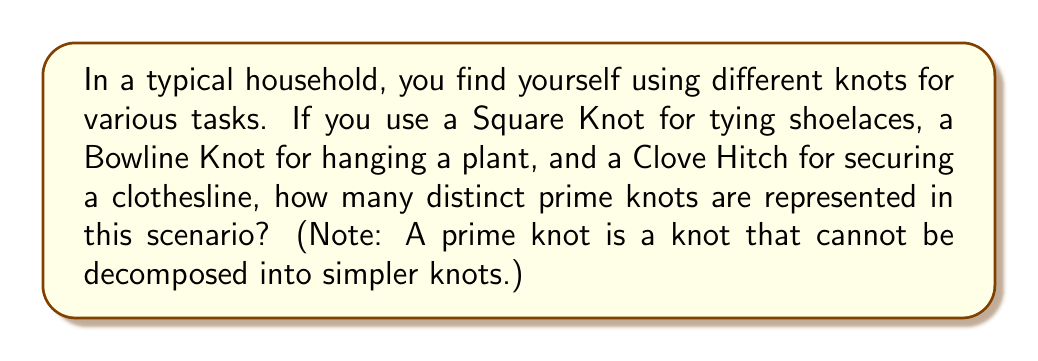Help me with this question. To solve this problem, we need to analyze each knot mentioned and determine if it's a prime knot:

1. Square Knot:
   The Square Knot, also known as the Reef Knot, is actually composed of two trefoil knots. In mathematical notation:
   Square Knot = Trefoil Knot # Mirror Trefoil Knot
   Where # denotes the connect sum operation.
   Therefore, the Square Knot is not a prime knot.

2. Bowline Knot:
   The Bowline Knot, when closed to form a loop, is equivalent to the Figure-8 Knot in knot theory. The Figure-8 Knot is a prime knot, denoted as $4_1$ in knot notation.

3. Clove Hitch:
   The Clove Hitch, when its ends are joined, forms two components that are linked. In knot theory, this is not considered a knot but rather a link. Therefore, it doesn't count as a prime knot in this context.

In summary:
- Square Knot: Not a prime knot
- Bowline Knot (Figure-8 Knot): Prime knot
- Clove Hitch: Not a knot (it's a link)

Thus, among the three knots used in this household scenario, only one distinct prime knot is represented.
Answer: 1 